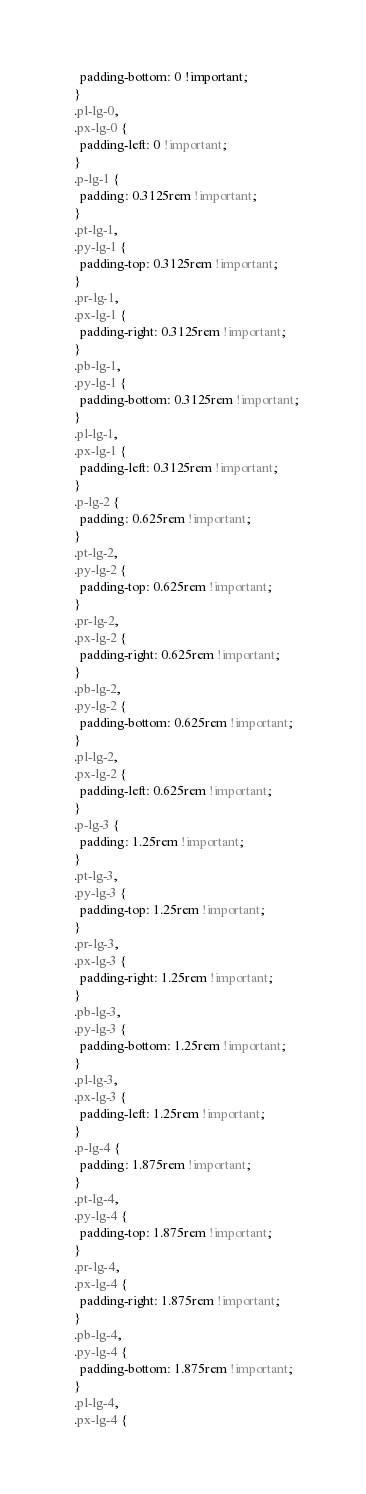Convert code to text. <code><loc_0><loc_0><loc_500><loc_500><_CSS_>    padding-bottom: 0 !important;
  }
  .pl-lg-0,
  .px-lg-0 {
    padding-left: 0 !important;
  }
  .p-lg-1 {
    padding: 0.3125rem !important;
  }
  .pt-lg-1,
  .py-lg-1 {
    padding-top: 0.3125rem !important;
  }
  .pr-lg-1,
  .px-lg-1 {
    padding-right: 0.3125rem !important;
  }
  .pb-lg-1,
  .py-lg-1 {
    padding-bottom: 0.3125rem !important;
  }
  .pl-lg-1,
  .px-lg-1 {
    padding-left: 0.3125rem !important;
  }
  .p-lg-2 {
    padding: 0.625rem !important;
  }
  .pt-lg-2,
  .py-lg-2 {
    padding-top: 0.625rem !important;
  }
  .pr-lg-2,
  .px-lg-2 {
    padding-right: 0.625rem !important;
  }
  .pb-lg-2,
  .py-lg-2 {
    padding-bottom: 0.625rem !important;
  }
  .pl-lg-2,
  .px-lg-2 {
    padding-left: 0.625rem !important;
  }
  .p-lg-3 {
    padding: 1.25rem !important;
  }
  .pt-lg-3,
  .py-lg-3 {
    padding-top: 1.25rem !important;
  }
  .pr-lg-3,
  .px-lg-3 {
    padding-right: 1.25rem !important;
  }
  .pb-lg-3,
  .py-lg-3 {
    padding-bottom: 1.25rem !important;
  }
  .pl-lg-3,
  .px-lg-3 {
    padding-left: 1.25rem !important;
  }
  .p-lg-4 {
    padding: 1.875rem !important;
  }
  .pt-lg-4,
  .py-lg-4 {
    padding-top: 1.875rem !important;
  }
  .pr-lg-4,
  .px-lg-4 {
    padding-right: 1.875rem !important;
  }
  .pb-lg-4,
  .py-lg-4 {
    padding-bottom: 1.875rem !important;
  }
  .pl-lg-4,
  .px-lg-4 {</code> 